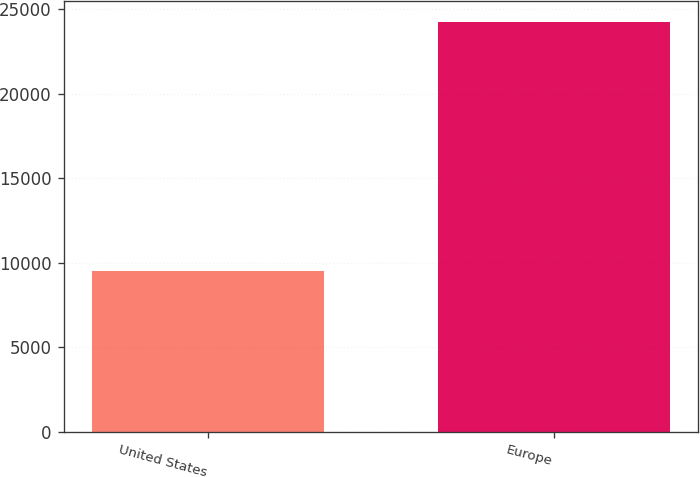<chart> <loc_0><loc_0><loc_500><loc_500><bar_chart><fcel>United States<fcel>Europe<nl><fcel>9485<fcel>24255<nl></chart> 